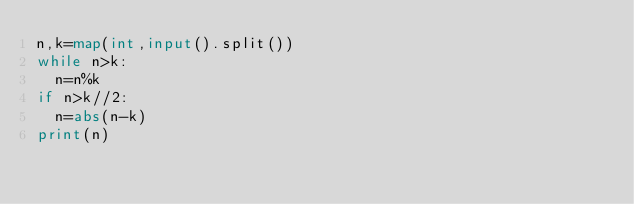Convert code to text. <code><loc_0><loc_0><loc_500><loc_500><_Python_>n,k=map(int,input().split())
while n>k:
  n=n%k
if n>k//2:
  n=abs(n-k)
print(n)</code> 